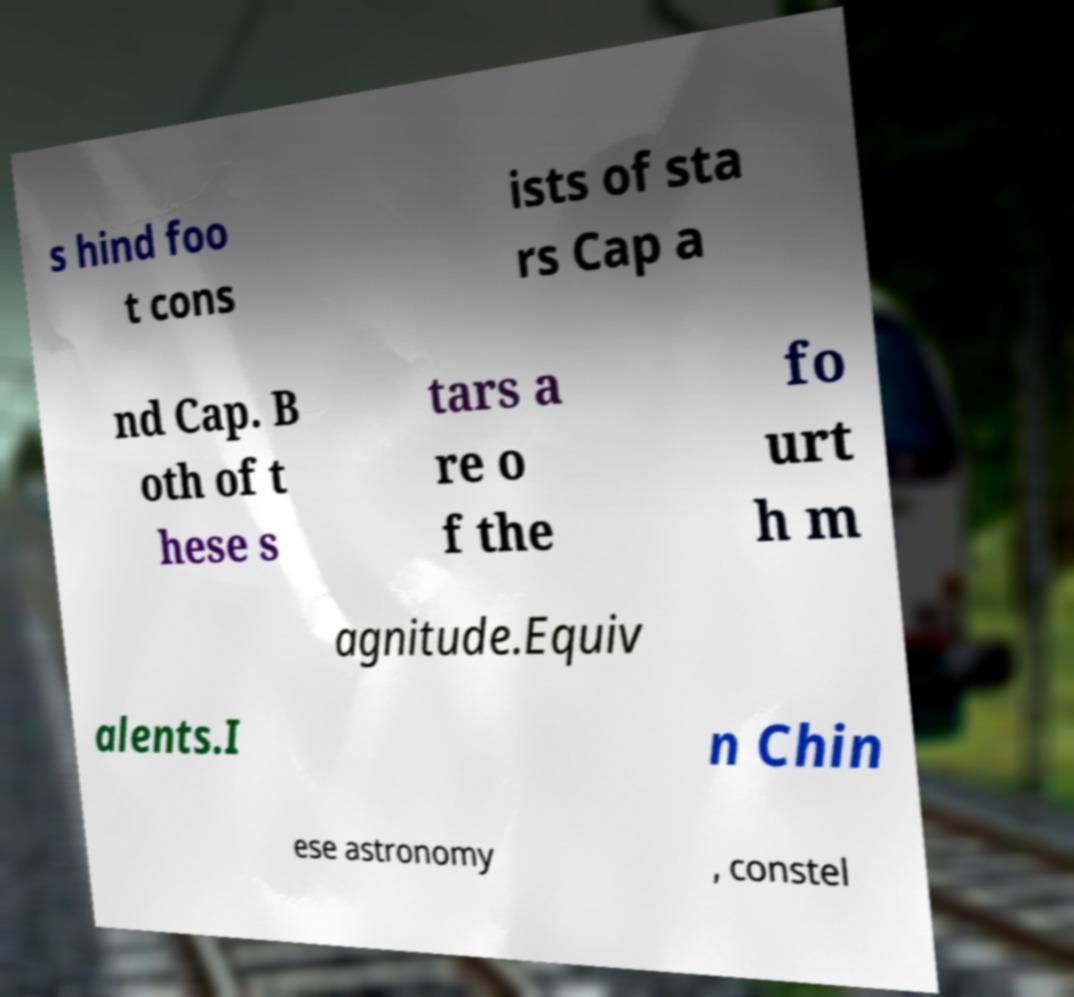There's text embedded in this image that I need extracted. Can you transcribe it verbatim? s hind foo t cons ists of sta rs Cap a nd Cap. B oth of t hese s tars a re o f the fo urt h m agnitude.Equiv alents.I n Chin ese astronomy , constel 